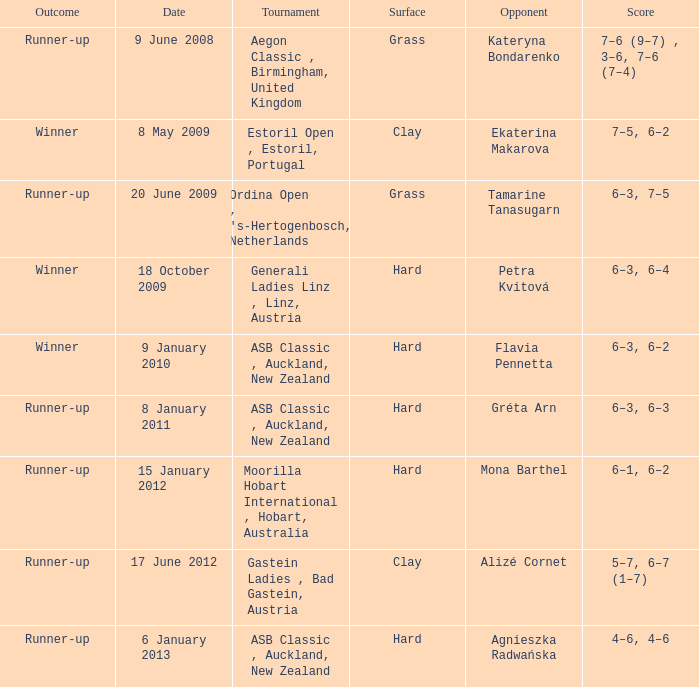What was the score in the tournament against Ekaterina Makarova? 7–5, 6–2. 